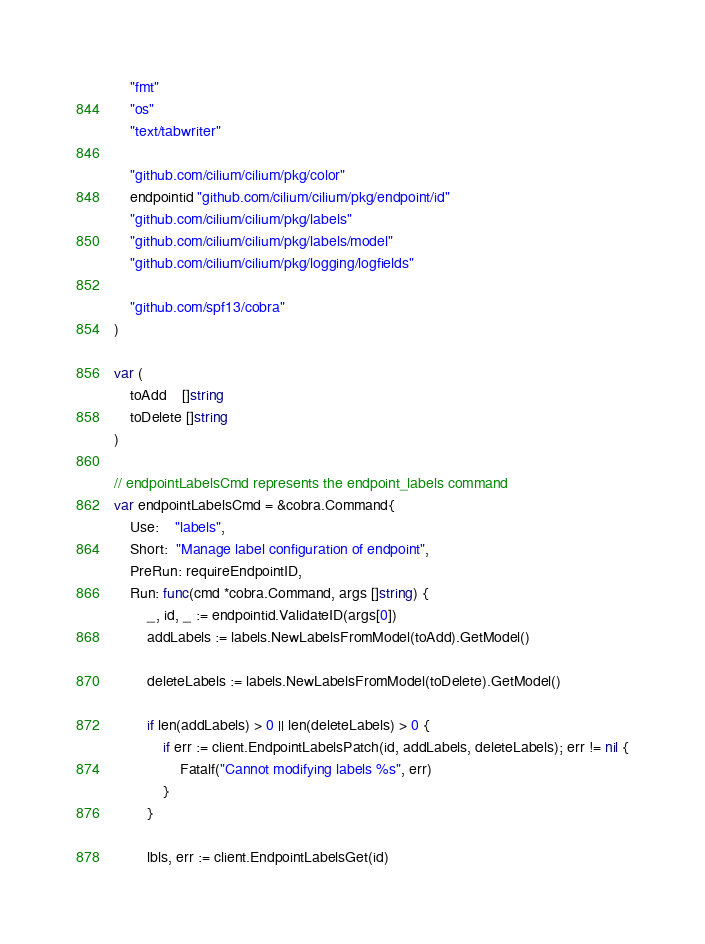<code> <loc_0><loc_0><loc_500><loc_500><_Go_>	"fmt"
	"os"
	"text/tabwriter"

	"github.com/cilium/cilium/pkg/color"
	endpointid "github.com/cilium/cilium/pkg/endpoint/id"
	"github.com/cilium/cilium/pkg/labels"
	"github.com/cilium/cilium/pkg/labels/model"
	"github.com/cilium/cilium/pkg/logging/logfields"

	"github.com/spf13/cobra"
)

var (
	toAdd    []string
	toDelete []string
)

// endpointLabelsCmd represents the endpoint_labels command
var endpointLabelsCmd = &cobra.Command{
	Use:    "labels",
	Short:  "Manage label configuration of endpoint",
	PreRun: requireEndpointID,
	Run: func(cmd *cobra.Command, args []string) {
		_, id, _ := endpointid.ValidateID(args[0])
		addLabels := labels.NewLabelsFromModel(toAdd).GetModel()

		deleteLabels := labels.NewLabelsFromModel(toDelete).GetModel()

		if len(addLabels) > 0 || len(deleteLabels) > 0 {
			if err := client.EndpointLabelsPatch(id, addLabels, deleteLabels); err != nil {
				Fatalf("Cannot modifying labels %s", err)
			}
		}

		lbls, err := client.EndpointLabelsGet(id)</code> 